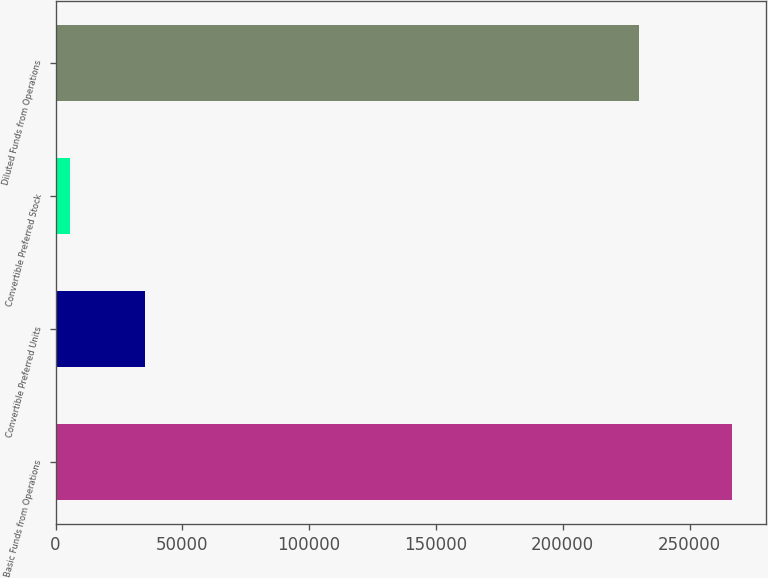<chart> <loc_0><loc_0><loc_500><loc_500><bar_chart><fcel>Basic Funds from Operations<fcel>Convertible Preferred Units<fcel>Convertible Preferred Stock<fcel>Diluted Funds from Operations<nl><fcel>266631<fcel>35139.9<fcel>5834<fcel>229961<nl></chart> 